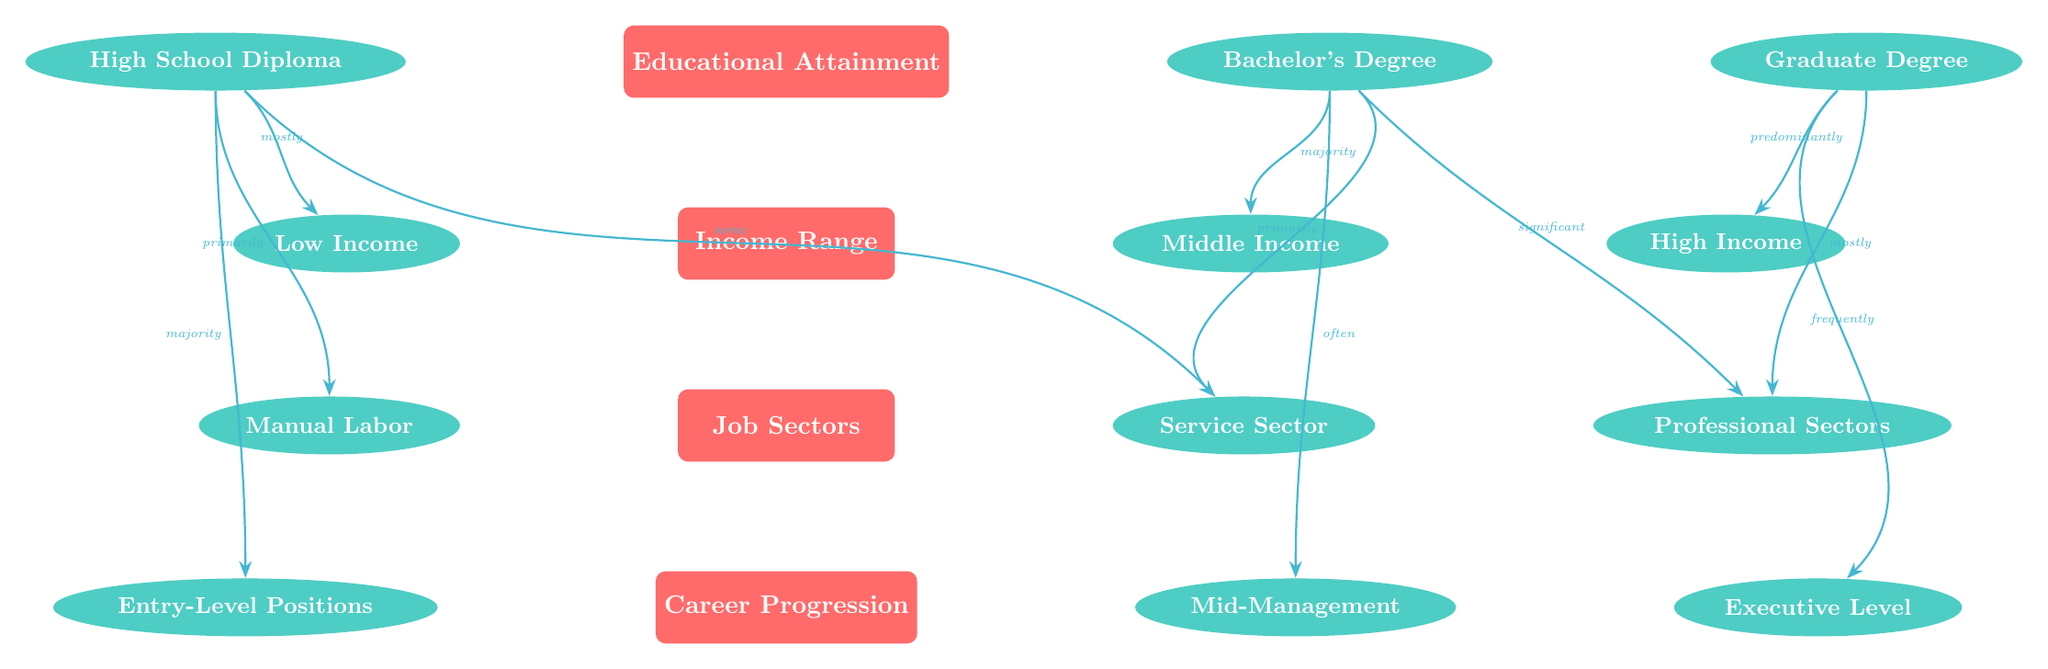What are the three levels of educational attainment in the diagram? The diagram shows three levels of educational attainment which are listed on the top: High School Diploma, Bachelor's Degree, and Graduate Degree.
Answer: High School Diploma, Bachelor's Degree, Graduate Degree Which income range is associated with a high school diploma? The diagram indicates that a high school diploma is mostly associated with the low-income range.
Answer: Low Income What job sector is primarily linked to individuals with a bachelor's degree? According to the diagram, the job sector that is primarily linked to individuals with a bachelor's degree is the service sector.
Answer: Service Sector What is the career progression level most commonly reached by high school graduates? The diagram shows that high school graduates most commonly reach entry-level positions in their careers.
Answer: Entry-Level Positions If someone holds a graduate degree, what income range are they predominantly in? The diagram indicates that individuals with a graduate degree are predominantly in the high-income range.
Answer: High Income How many subcategories are there for job sectors? The diagram lists three subcategories for job sectors: Manual Labor, Service Sector, and Professional Sectors.
Answer: Three What is the significance of the educational attainment level when considering career progression? The diagram illustrates that as educational attainment increases, the career progression level also increases, moving from entry-level positions to executive levels.
Answer: Increases What type of relationship exists between a bachelor's degree and middle income? The diagram demonstrates a majority relationship, indicating that most individuals with a bachelor's degree fall within the middle-income range.
Answer: Majority What is the flow direction from the educational attainment category to the job sectors category? The flow direction is vertical with edges indicating relationships such as "primarily," "majority," and "significant," showcasing the influence of educational attainment on job sectors.
Answer: Vertical 